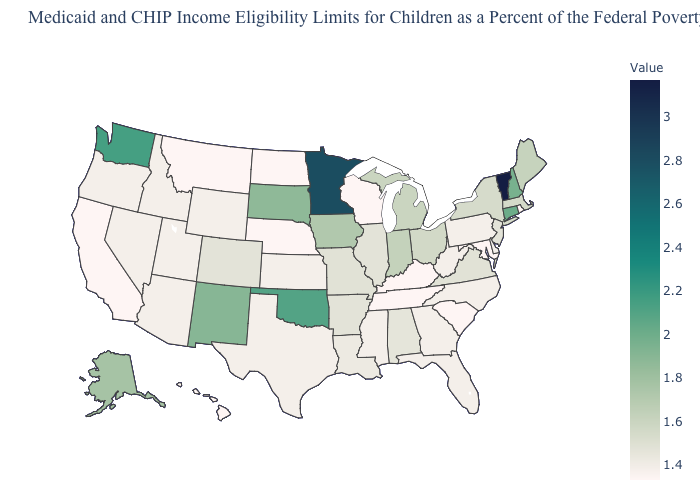Which states have the highest value in the USA?
Keep it brief. Vermont. Does Washington have the lowest value in the West?
Write a very short answer. No. Is the legend a continuous bar?
Give a very brief answer. Yes. Which states have the highest value in the USA?
Be succinct. Vermont. Does Colorado have a lower value than Vermont?
Write a very short answer. Yes. Does Vermont have the highest value in the USA?
Keep it brief. Yes. Which states hav the highest value in the South?
Be succinct. Oklahoma. 